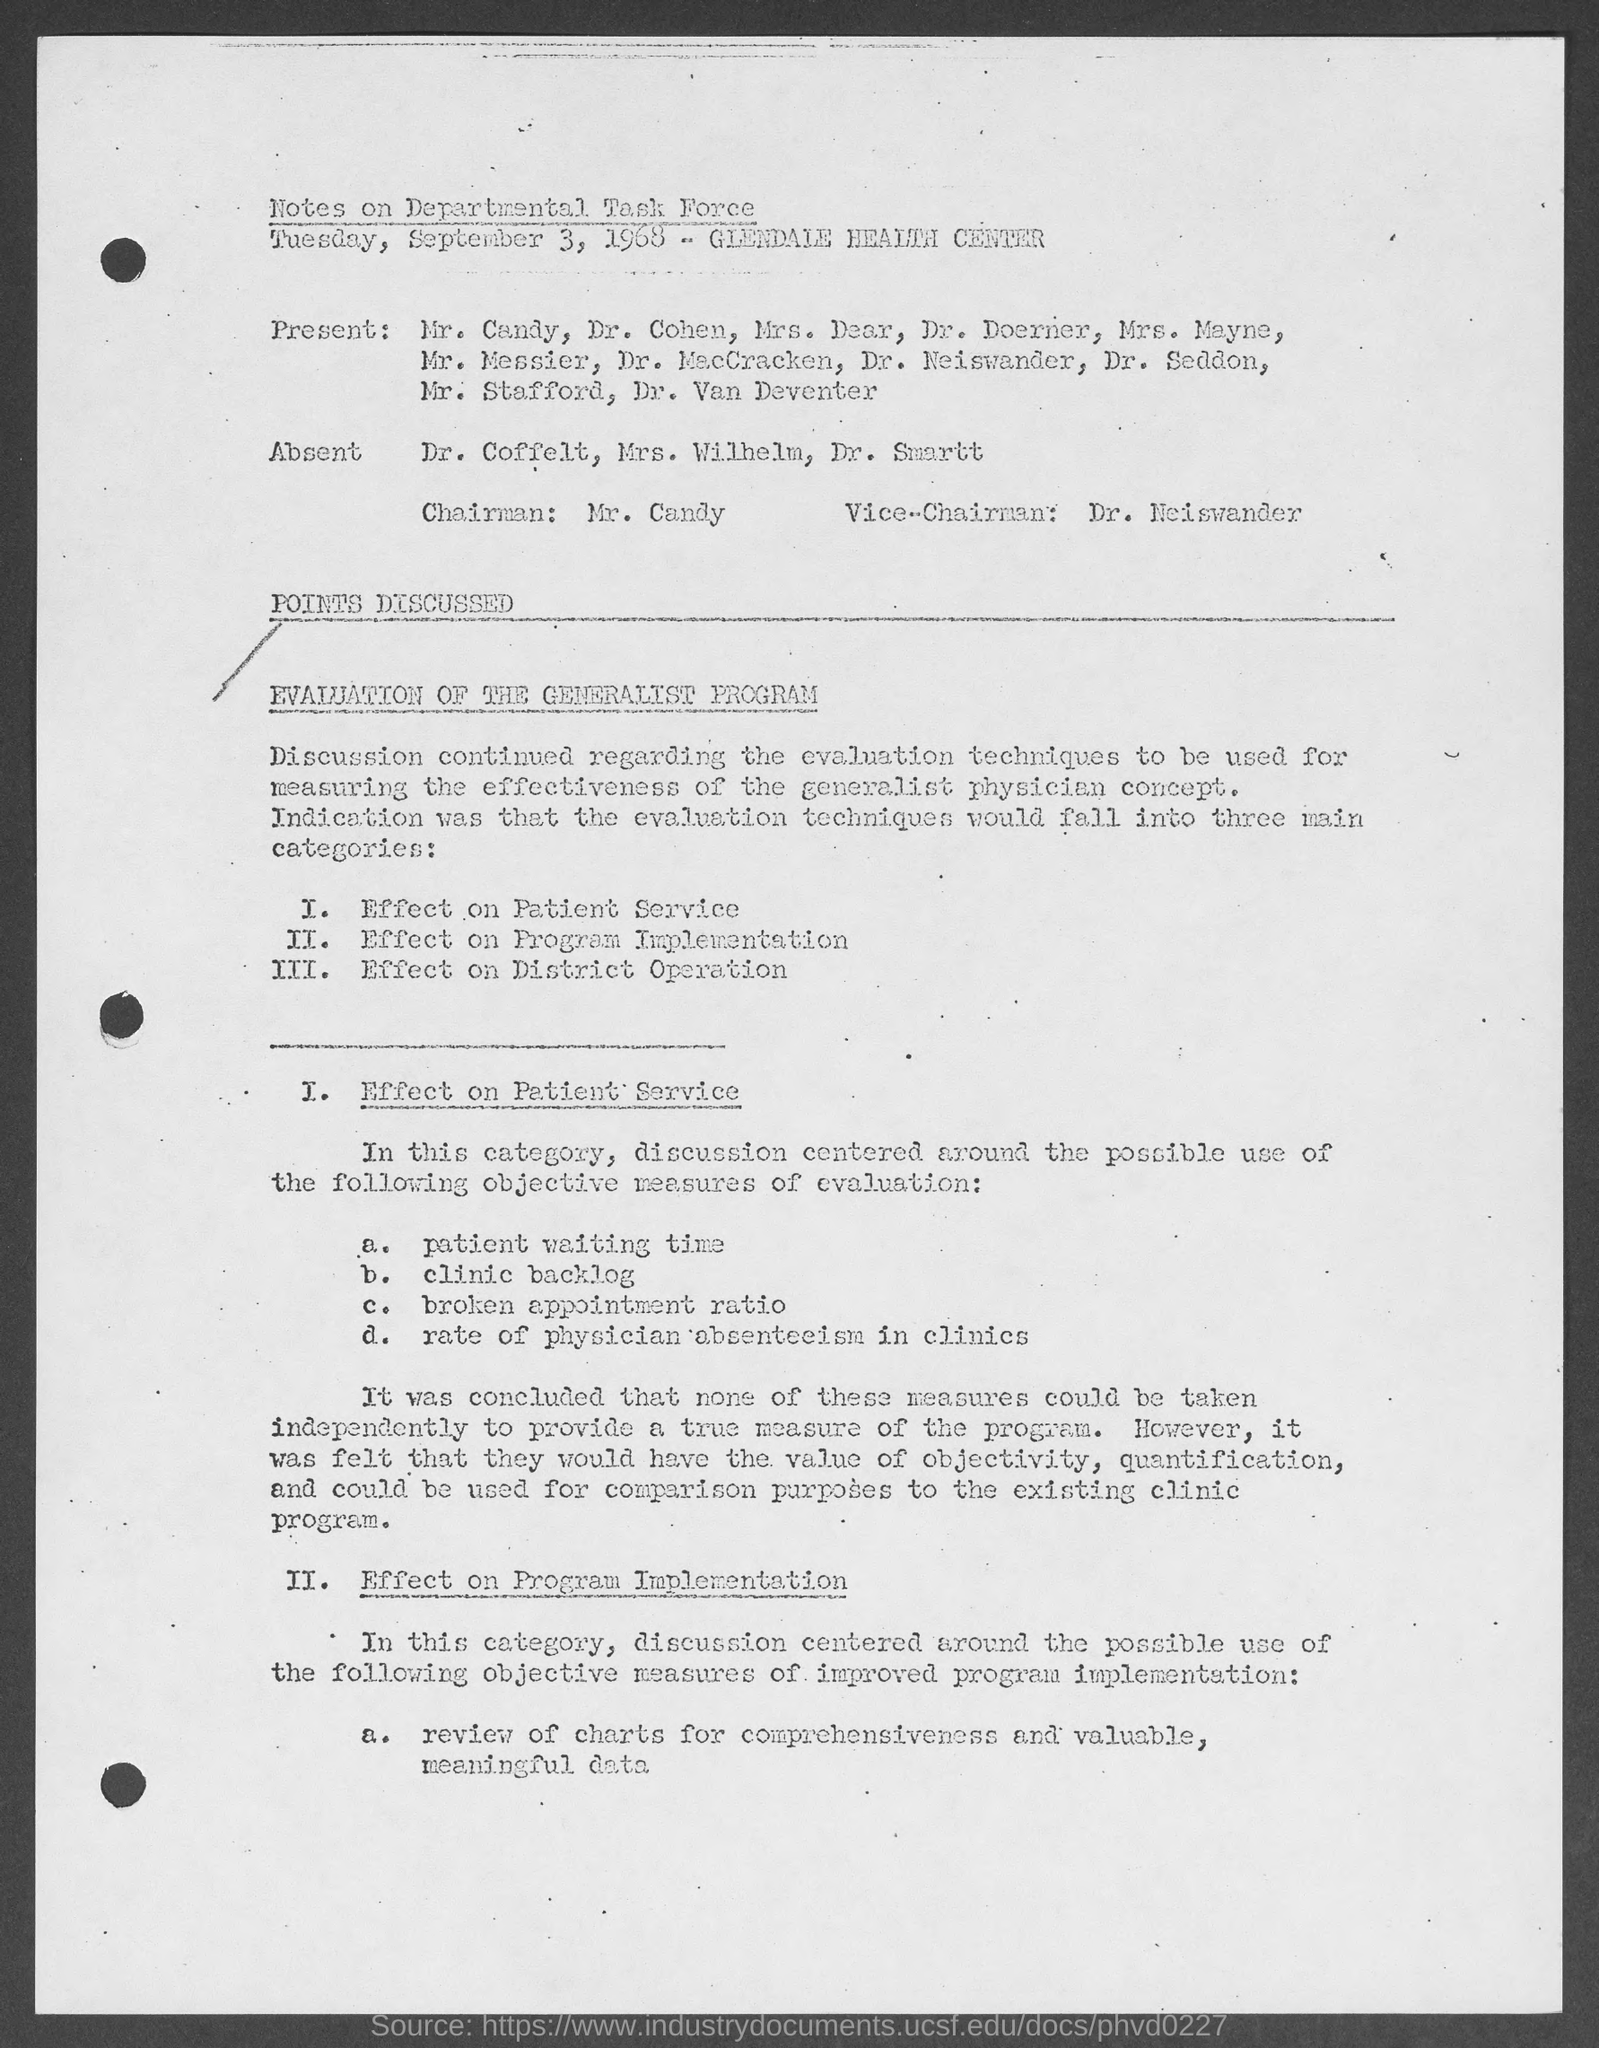Draw attention to some important aspects in this diagram. The Vice-Chairman mentioned in the document is Dr. Neiswander. The Chairman mentioned in the document is Mr. Candy. The following individuals were absent according to the Notes on Departmental Task Force: Dr. Coffelt, Mrs. Wilhelm, and Dr. Smartt. 